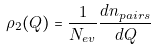Convert formula to latex. <formula><loc_0><loc_0><loc_500><loc_500>\rho _ { 2 } ( Q ) = \frac { 1 } { N _ { e v } } \frac { d n _ { p a i r s } } { d Q }</formula> 